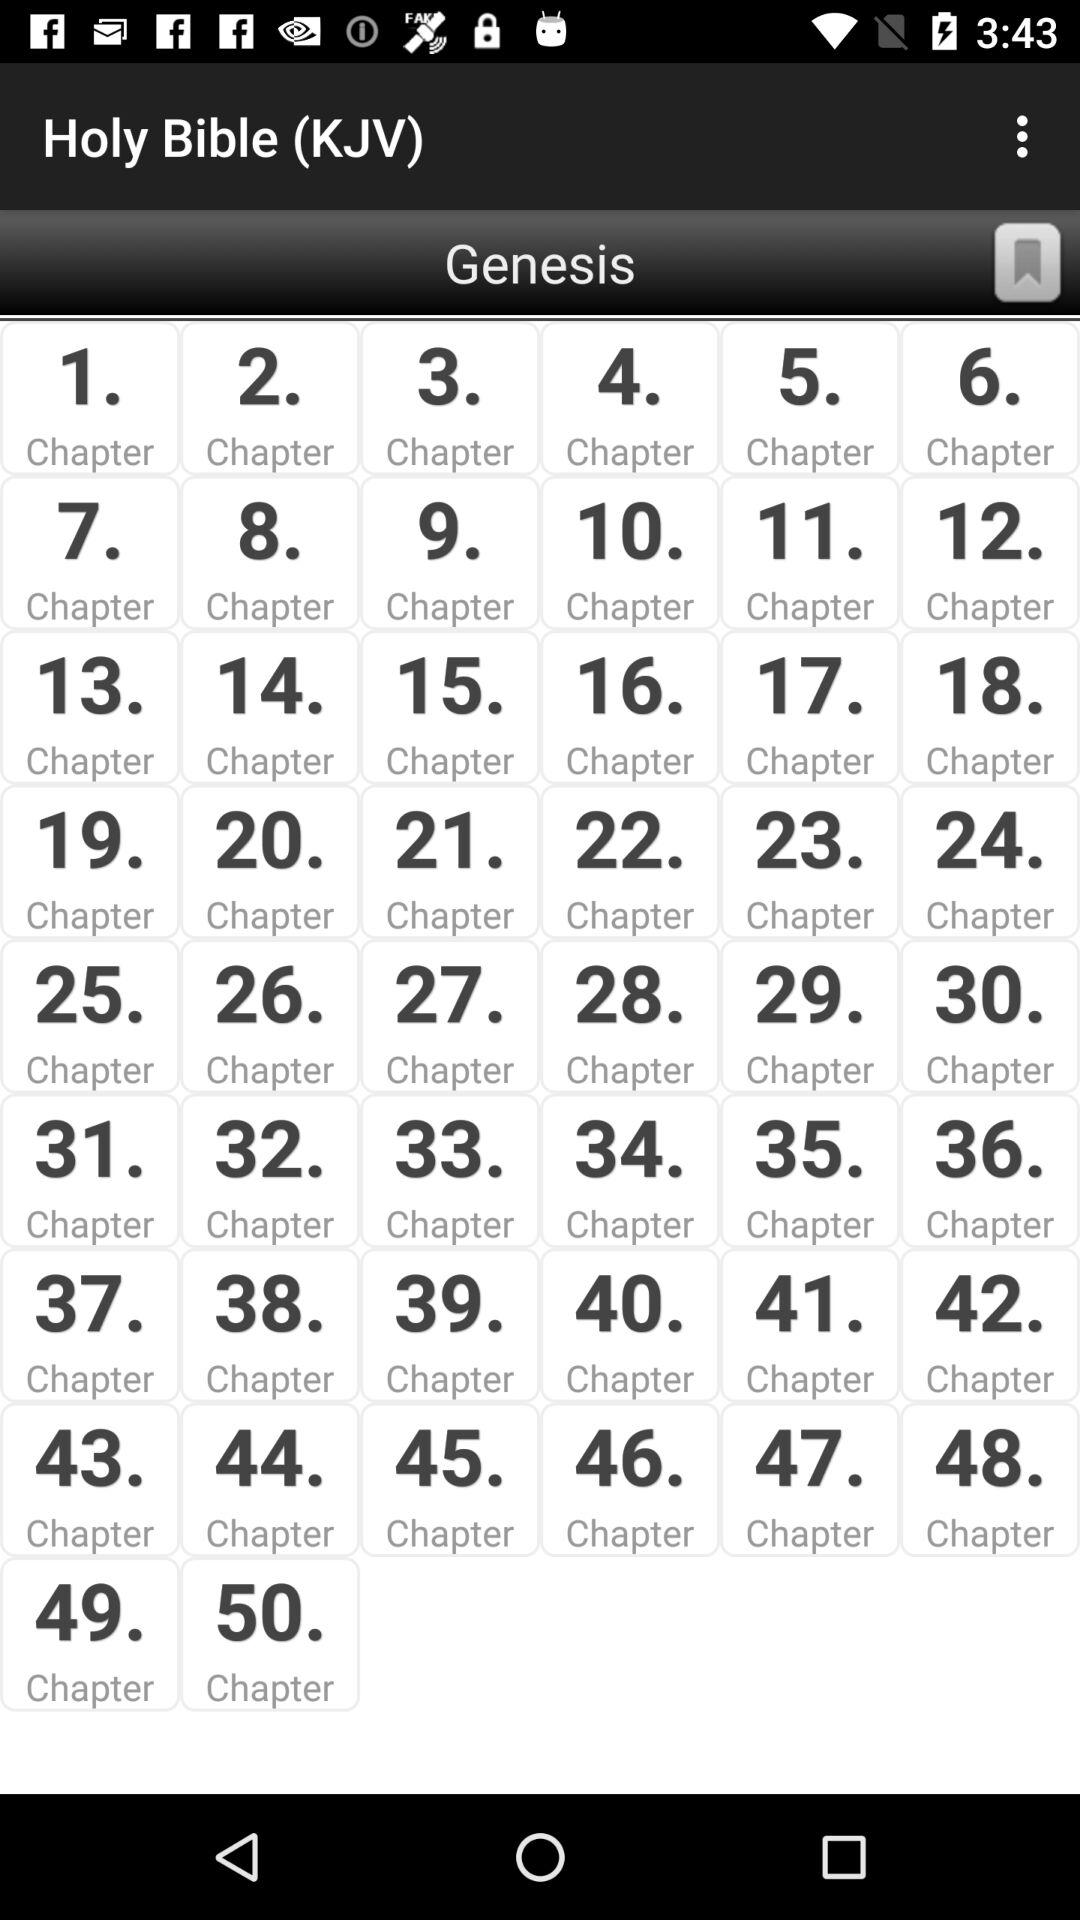What is the application name? The application name is "Holy Bible (KJV)". 